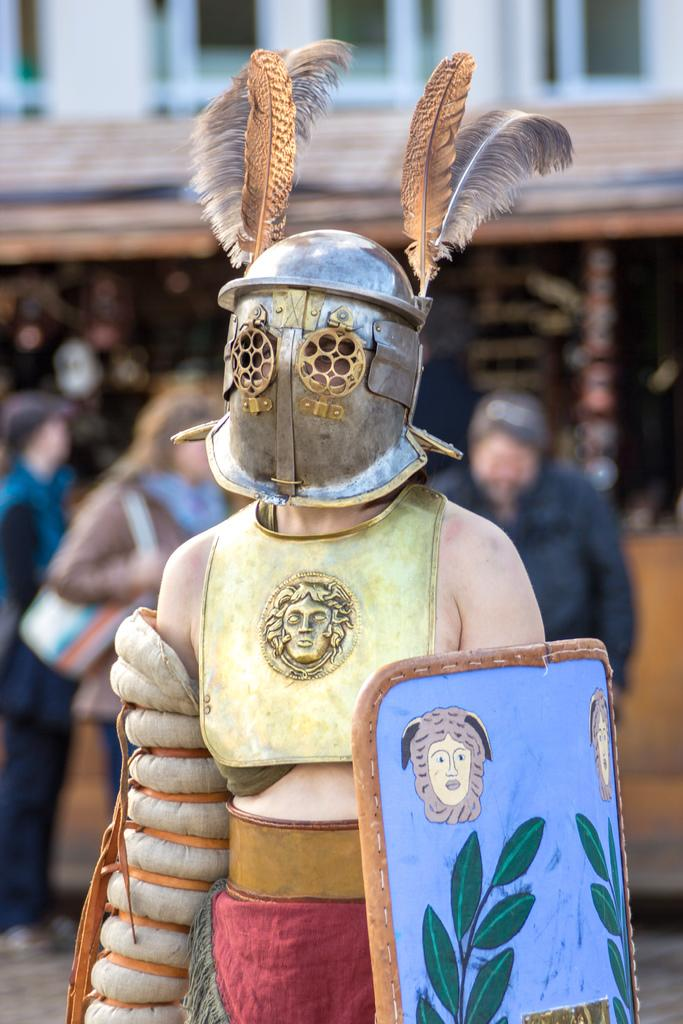Who is the main subject in the image? There is a woman in the image. What is the woman wearing? The woman is wearing shields. Are there any other people in the image? Yes, there are two men and a woman behind the woman in the image. Can you describe the background of the image? The background of the image is blurry. What type of brush is the woman using to paint the committee in the image? There is no brush or committee present in the image; it features a woman wearing shields and other people behind her. 